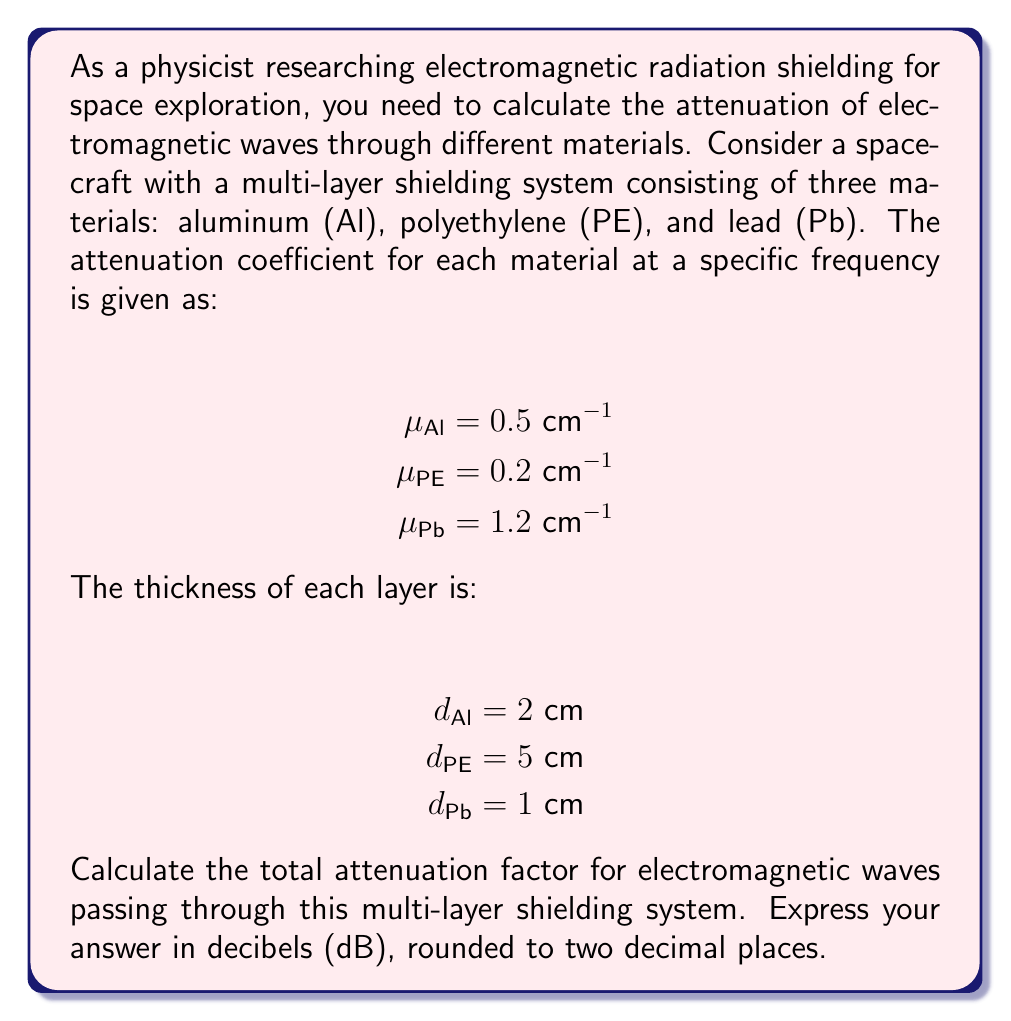Can you answer this question? To solve this problem, we'll follow these steps:

1) The attenuation factor for a single material is given by the Beer-Lambert law:

   $A = e^{-\mu d}$

   where $\mu$ is the attenuation coefficient and $d$ is the thickness.

2) For a multi-layer system, we multiply the attenuation factors of each layer:

   $A_{total} = A_{Al} \cdot A_{PE} \cdot A_{Pb}$

3) Let's calculate the attenuation factor for each material:

   $A_{Al} = e^{-\mu_{Al} d_{Al}} = e^{-0.5 \cdot 2} = e^{-1} \approx 0.3679$
   
   $A_{PE} = e^{-\mu_{PE} d_{PE}} = e^{-0.2 \cdot 5} = e^{-1} \approx 0.3679$
   
   $A_{Pb} = e^{-\mu_{Pb} d_{Pb}} = e^{-1.2 \cdot 1} = e^{-1.2} \approx 0.3012$

4) Now, let's multiply these factors:

   $A_{total} = 0.3679 \cdot 0.3679 \cdot 0.3012 \approx 0.0407$

5) To express this in decibels, we use the formula:

   $A_{dB} = -10 \log_{10}(A_{total})$

6) Plugging in our value:

   $A_{dB} = -10 \log_{10}(0.0407) \approx 13.90 \text{ dB}$

7) Rounding to two decimal places, we get 13.90 dB.
Answer: 13.90 dB 